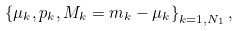<formula> <loc_0><loc_0><loc_500><loc_500>\left \{ \mu _ { k } , p _ { k } , M _ { k } = m _ { k } - \mu _ { k } \right \} _ { k = 1 , N _ { 1 } } ,</formula> 